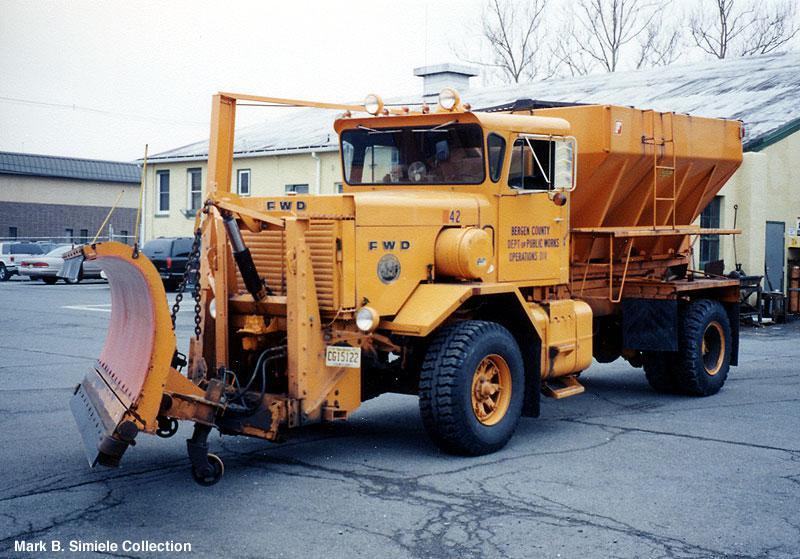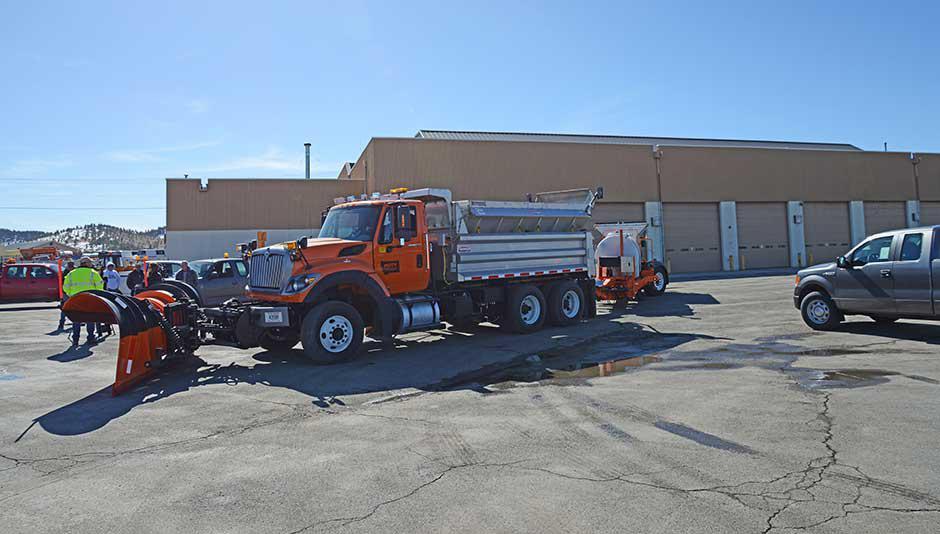The first image is the image on the left, the second image is the image on the right. For the images displayed, is the sentence "In one image, at least one yellow truck with snow blade is on a snowy road, while a second image shows snow removal equipment on clear pavement." factually correct? Answer yes or no. No. The first image is the image on the left, the second image is the image on the right. Evaluate the accuracy of this statement regarding the images: "Snow is visible along the roadside in one of the images featuring a snow plow truck.". Is it true? Answer yes or no. No. 